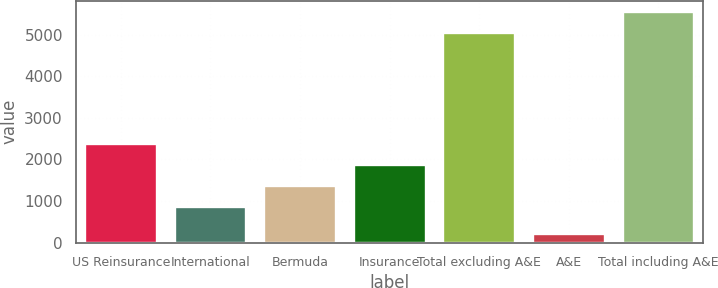Convert chart to OTSL. <chart><loc_0><loc_0><loc_500><loc_500><bar_chart><fcel>US Reinsurance<fcel>International<fcel>Bermuda<fcel>Insurance<fcel>Total excluding A&E<fcel>A&E<fcel>Total including A&E<nl><fcel>2367.51<fcel>857.7<fcel>1360.97<fcel>1864.24<fcel>5032.8<fcel>210.9<fcel>5536.07<nl></chart> 